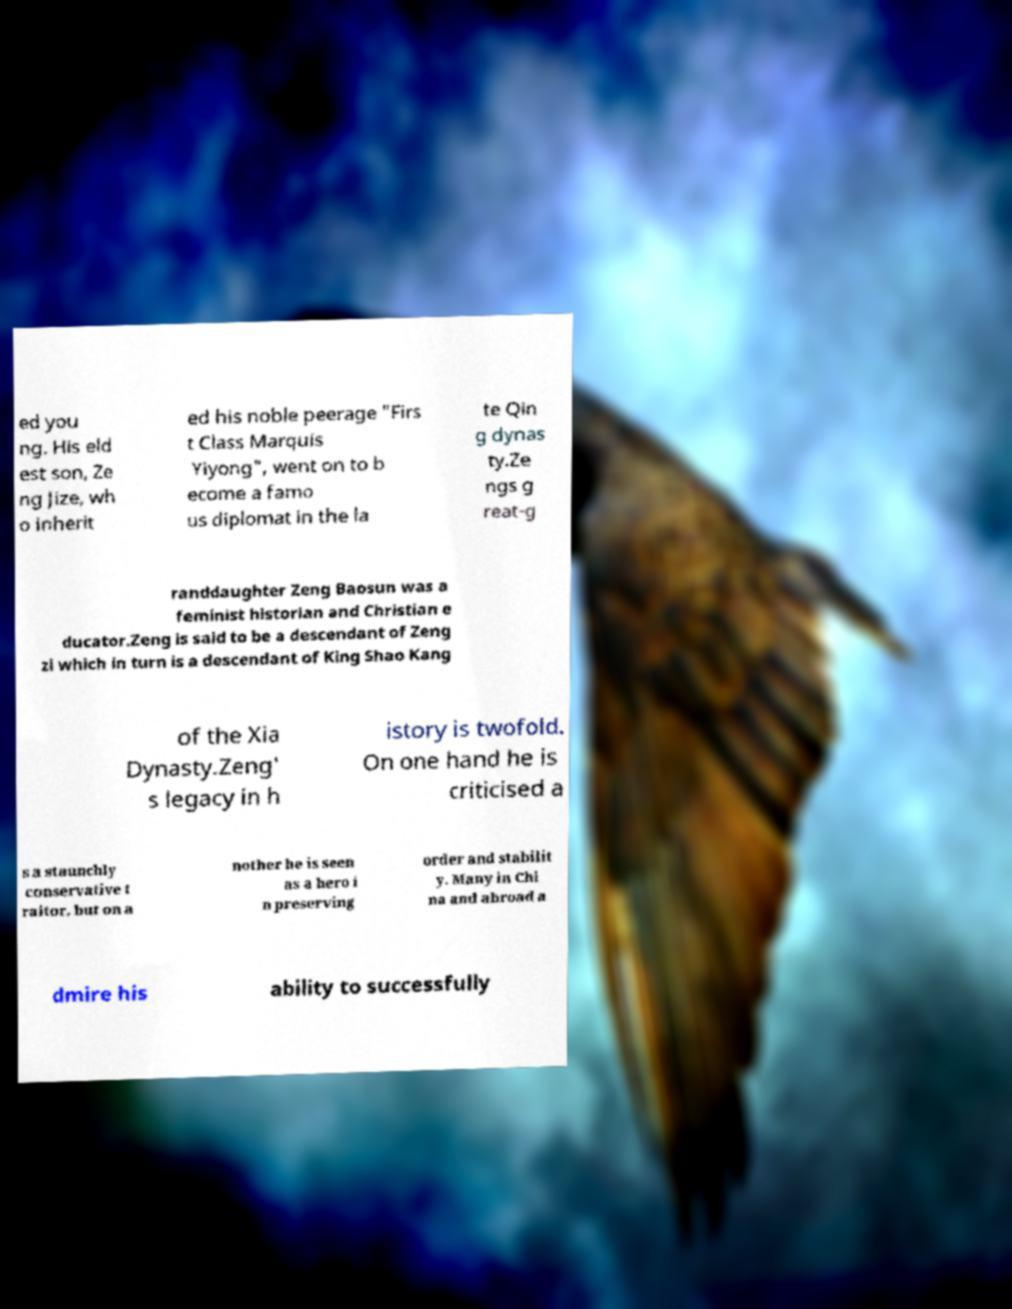Can you accurately transcribe the text from the provided image for me? ed you ng. His eld est son, Ze ng Jize, wh o inherit ed his noble peerage "Firs t Class Marquis Yiyong", went on to b ecome a famo us diplomat in the la te Qin g dynas ty.Ze ngs g reat-g randdaughter Zeng Baosun was a feminist historian and Christian e ducator.Zeng is said to be a descendant of Zeng zi which in turn is a descendant of King Shao Kang of the Xia Dynasty.Zeng' s legacy in h istory is twofold. On one hand he is criticised a s a staunchly conservative t raitor, but on a nother he is seen as a hero i n preserving order and stabilit y. Many in Chi na and abroad a dmire his ability to successfully 